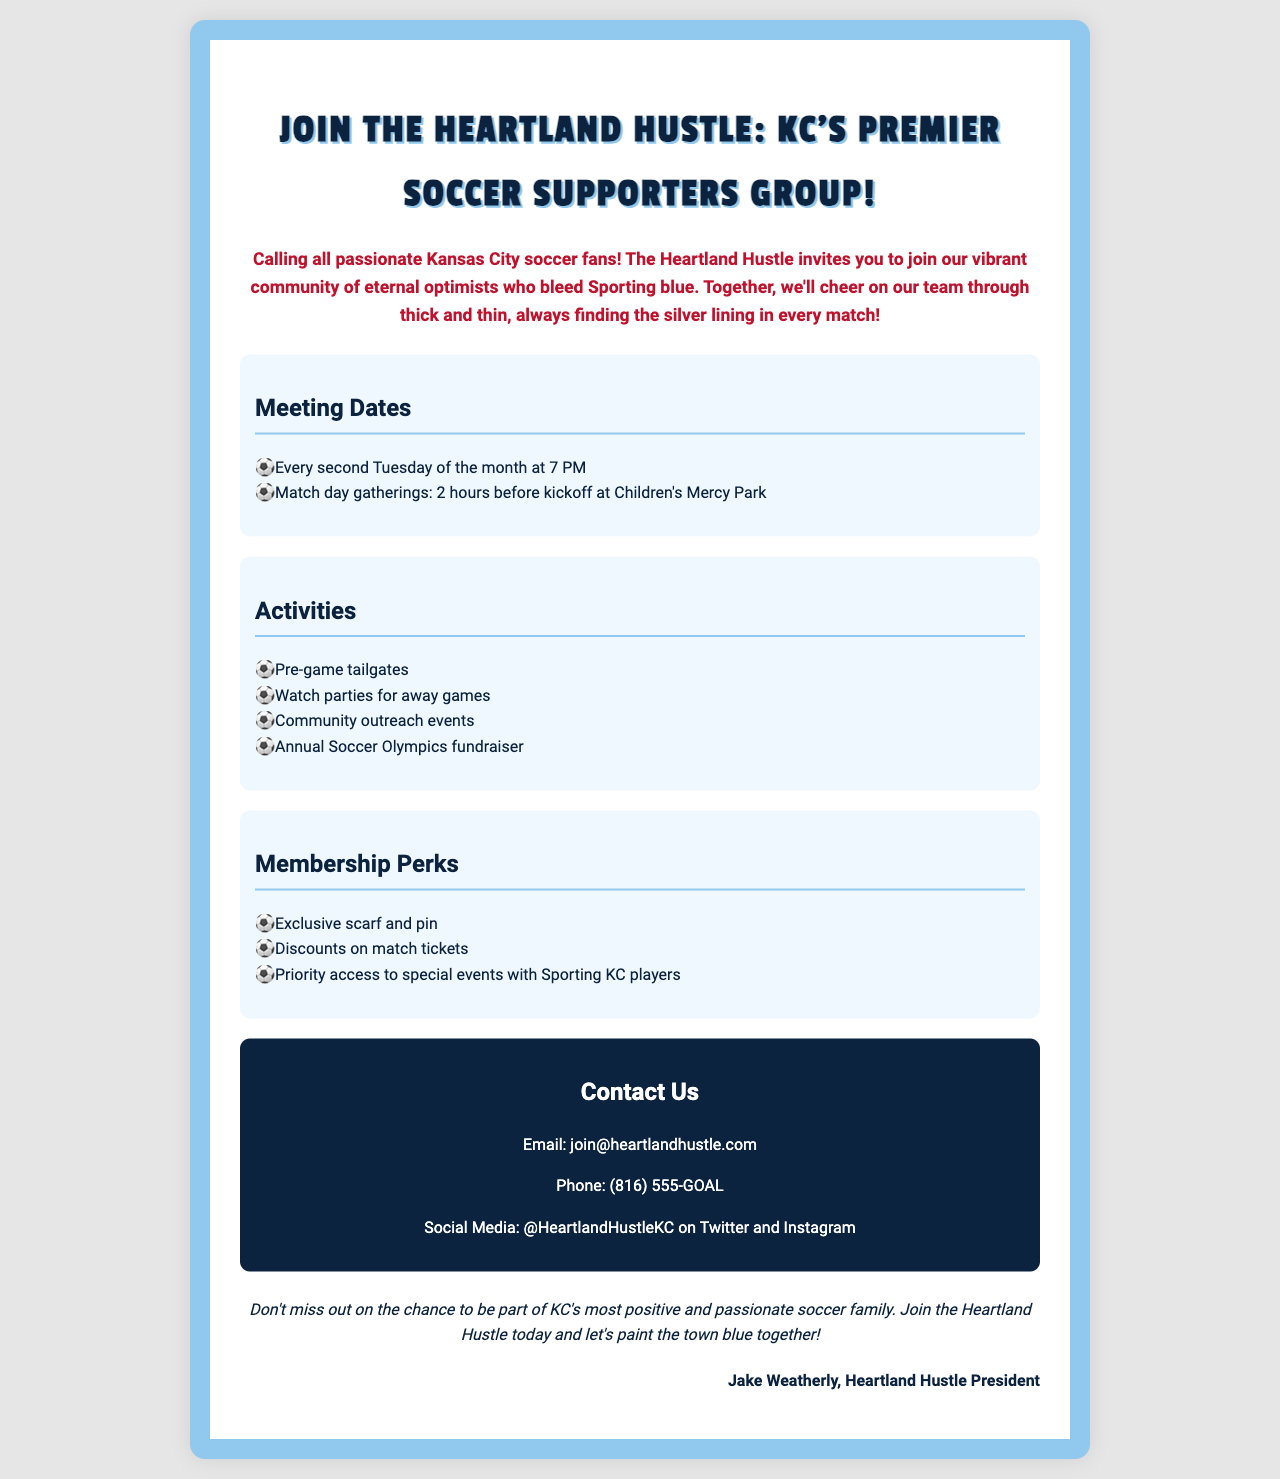What is the name of the supporters group? The document states the name of the supporters group as "Heartland Hustle."
Answer: Heartland Hustle When do the regular meetings take place? The document mentions regular meetings occur every second Tuesday of the month at 7 PM.
Answer: Every second Tuesday of the month at 7 PM What is one of the membership perks mentioned? The document lists "Exclusive scarf and pin" as one of the membership perks.
Answer: Exclusive scarf and pin What activities does the group organize? The document provides a list of activities, including "Pre-game tailgates."
Answer: Pre-game tailgates How can members contact the group? The document provides contact details including an email which is "join@heartlandhustle.com."
Answer: join@heartlandhustle.com What is the theme of the group's message? The document conveys a theme of positivity and support, stating they are “the most positive and passionate soccer family.”
Answer: Positivity and support What is the group's social media handle? The document specifies the social media handle as "@HeartlandHustleKC."
Answer: @HeartlandHustleKC What is the signature of the document? The closing signature is provided by "Jake Weatherly, Heartland Hustle President."
Answer: Jake Weatherly, Heartland Hustle President 